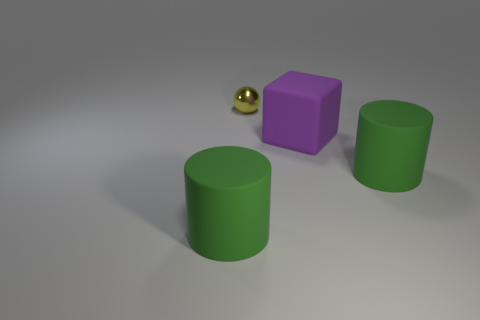Are there any other things that are the same shape as the tiny yellow object?
Provide a succinct answer. No. Are there any other things that have the same size as the metal sphere?
Offer a very short reply. No. What number of other objects are there of the same color as the ball?
Your answer should be compact. 0. What number of big purple things have the same material as the ball?
Provide a succinct answer. 0. How many cyan objects are either cylinders or large cubes?
Your answer should be very brief. 0. Is there anything else that is the same material as the sphere?
Offer a very short reply. No. Are the green cylinder to the right of the purple object and the purple cube made of the same material?
Give a very brief answer. Yes. What number of objects are red metallic balls or big matte objects on the left side of the purple matte block?
Provide a short and direct response. 1. There is a large green matte cylinder that is behind the rubber thing that is on the left side of the purple block; what number of cylinders are in front of it?
Give a very brief answer. 1. Is there a large green rubber cylinder that is on the right side of the large rubber object that is to the left of the purple thing?
Provide a succinct answer. Yes. 